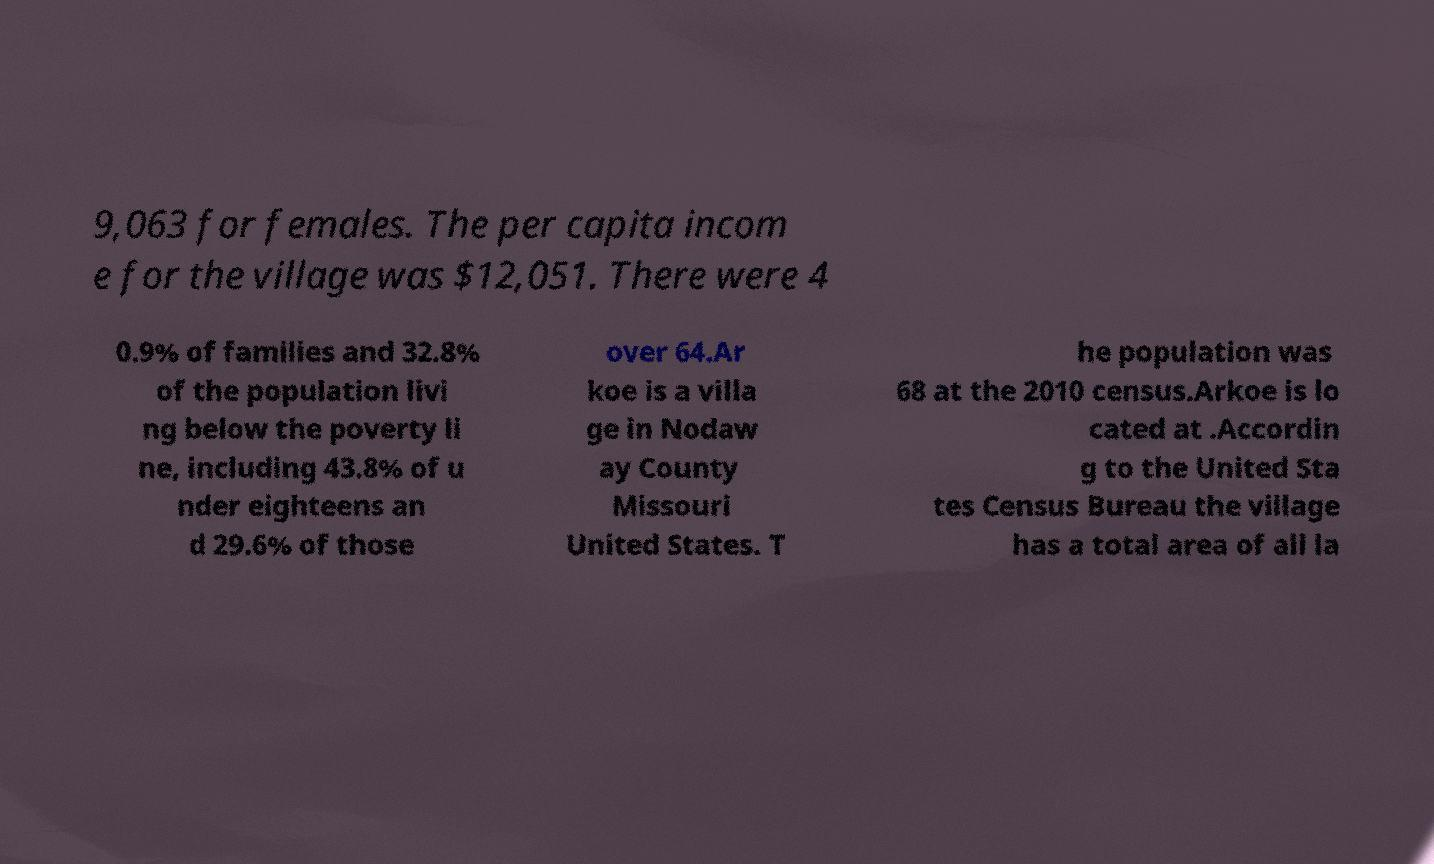Could you assist in decoding the text presented in this image and type it out clearly? 9,063 for females. The per capita incom e for the village was $12,051. There were 4 0.9% of families and 32.8% of the population livi ng below the poverty li ne, including 43.8% of u nder eighteens an d 29.6% of those over 64.Ar koe is a villa ge in Nodaw ay County Missouri United States. T he population was 68 at the 2010 census.Arkoe is lo cated at .Accordin g to the United Sta tes Census Bureau the village has a total area of all la 